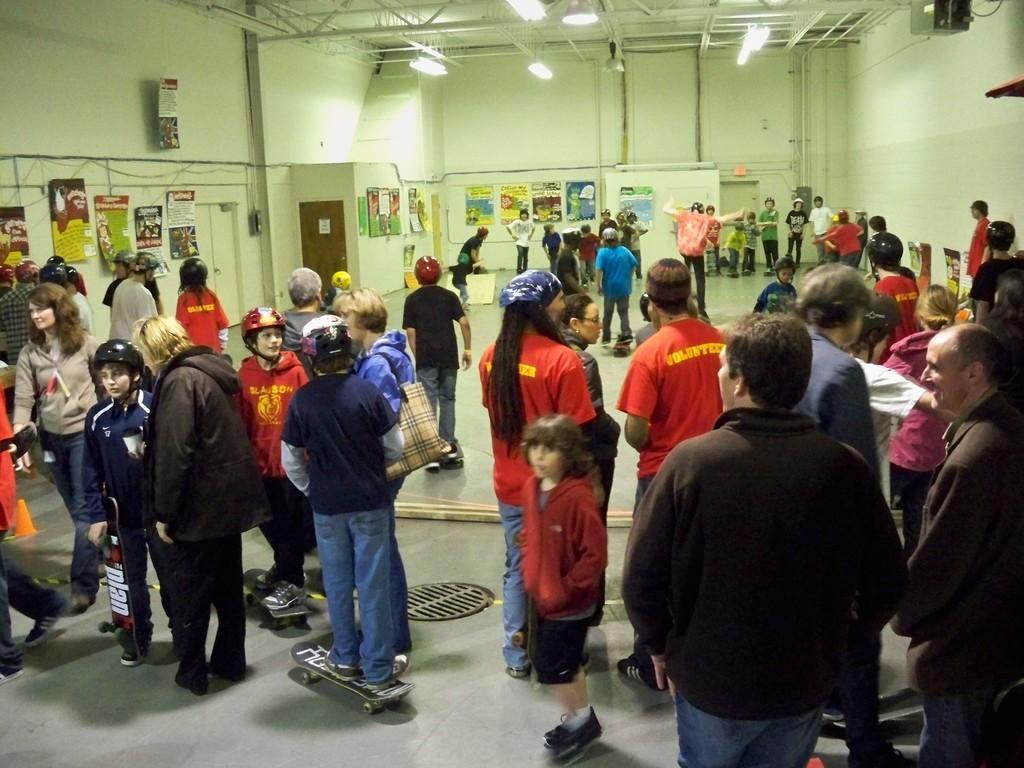Could you give a brief overview of what you see in this image? This picture is clicked inside the room and we can see the group of people seems to be standing on the ground in and we can see the skateboards, helmets. In the background we can see the wall, door, text and some pictures on the posters which are attached to the wall and we can see the metal rods, lights and many other items. 